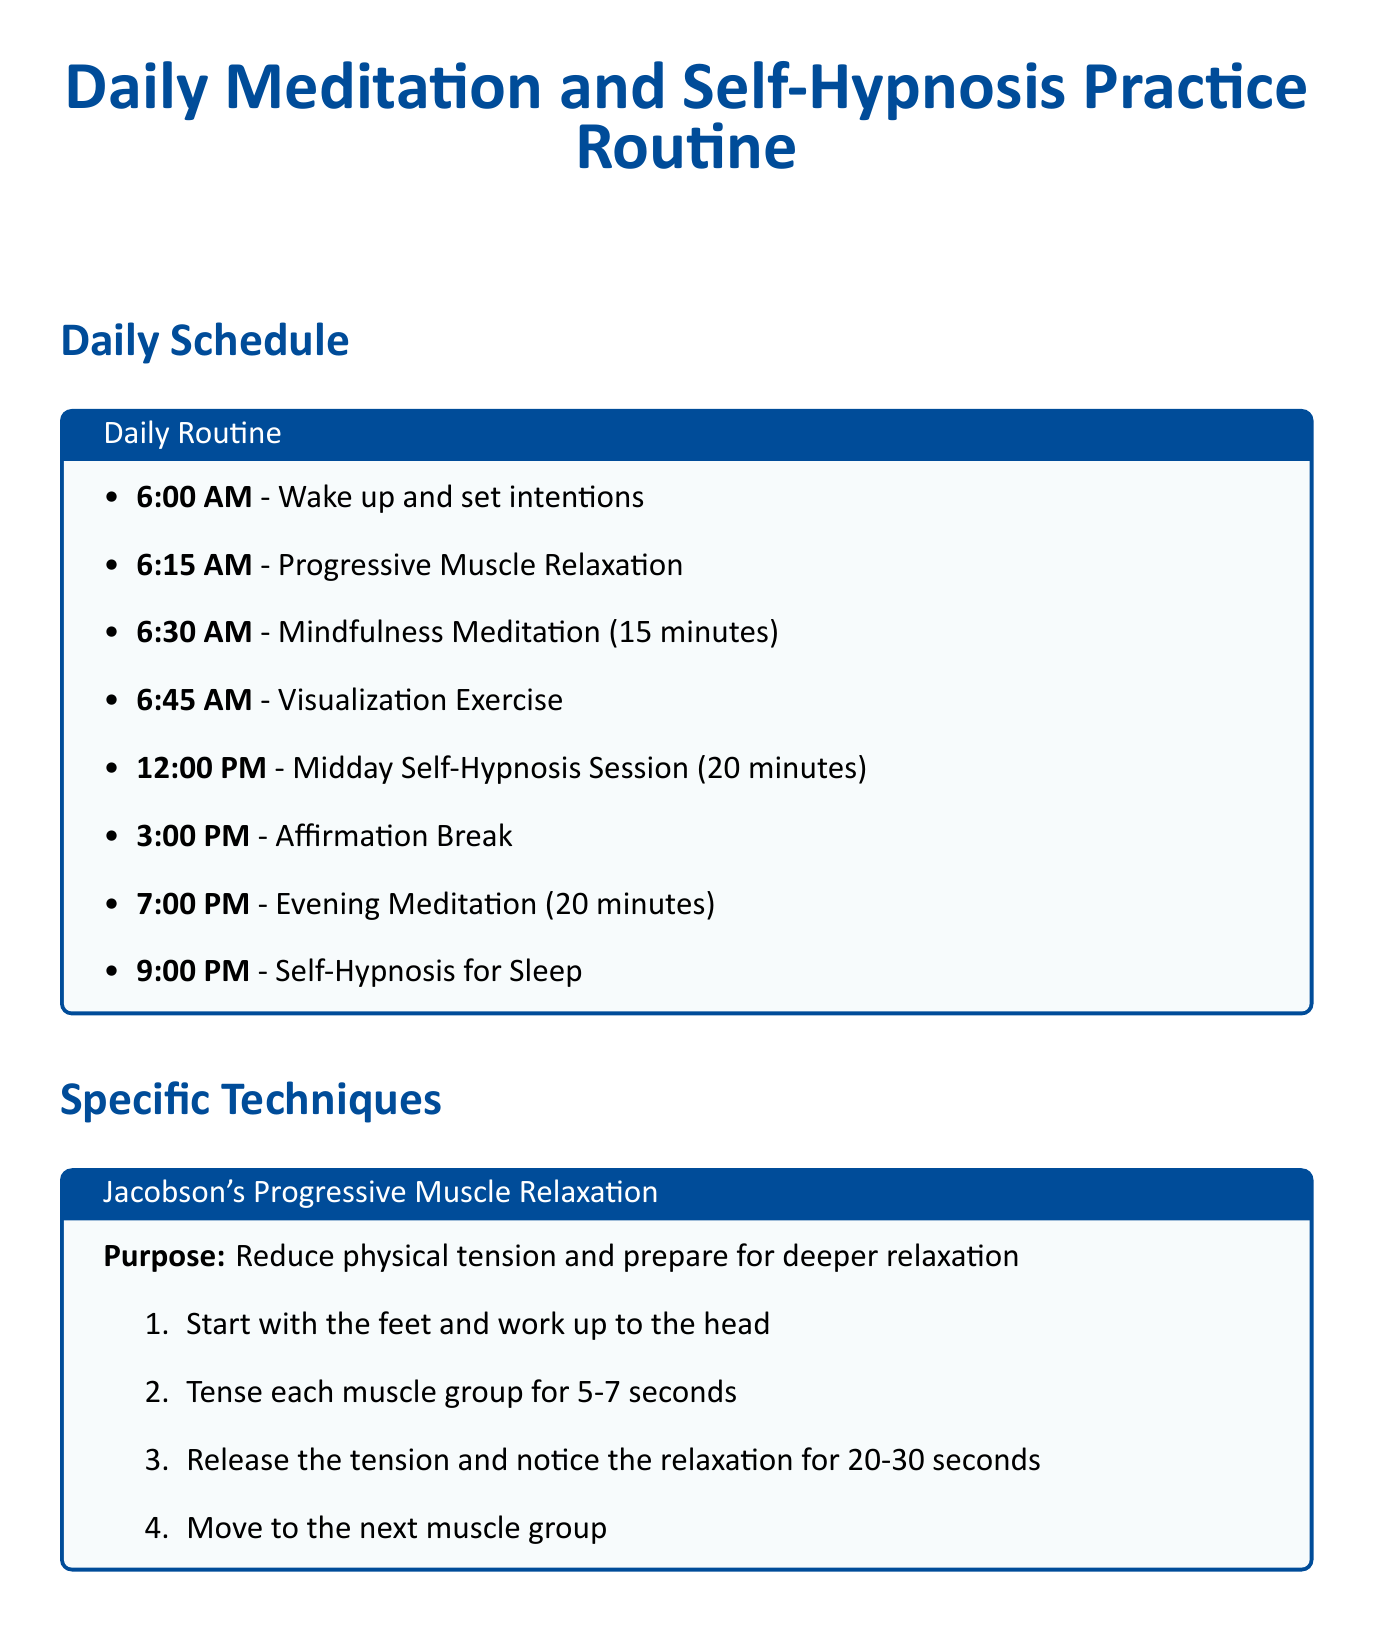What activity starts at 6:00 AM? The document lists "Wake up and set intentions" as the first activity in the daily routine.
Answer: Wake up and set intentions How long is the Midday Self-Hypnosis Session? The document specifies that the Midday Self-Hypnosis Session lasts for 20 minutes.
Answer: 20 minutes What is the purpose of Jacobson's Progressive Muscle Relaxation? The document describes the purpose as reducing physical tension and preparing for deeper relaxation.
Answer: Reduce physical tension and prepare for deeper relaxation What technique is focused on improving emotional awareness? The document identifies "Mindfulness-Based Stress Reduction (MBSR)" as the technique for improving emotional awareness.
Answer: Mindfulness-Based Stress Reduction (MBSR) How many points are touched during the 61-Point Relaxation Technique? The document states that 61 points are mentally touched during this technique.
Answer: 61 points Which mobile app is mentioned for guided meditations? The document lists "Headspace" as a mobile app for guided meditations and mindfulness exercises.
Answer: Headspace What time is the Evening Meditation scheduled for? The schedule indicates that the Evening Meditation is set for 7:00 PM.
Answer: 7:00 PM What technique is suggested for self-confidence? The document recommends "Mirror Work" as the technique for building self-confidence.
Answer: Mirror Work What is the final activity of the daily routine? According to the document, the last activity of the daily routine is "Self-Hypnosis for Sleep."
Answer: Self-Hypnosis for Sleep 